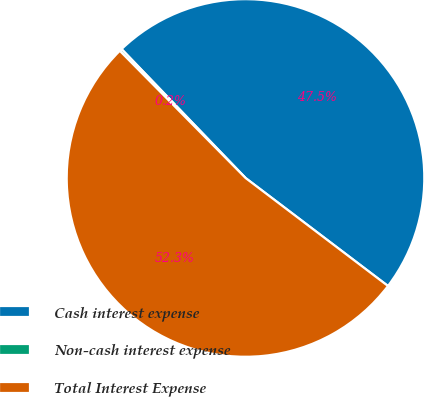<chart> <loc_0><loc_0><loc_500><loc_500><pie_chart><fcel>Cash interest expense<fcel>Non-cash interest expense<fcel>Total Interest Expense<nl><fcel>47.51%<fcel>0.22%<fcel>52.26%<nl></chart> 